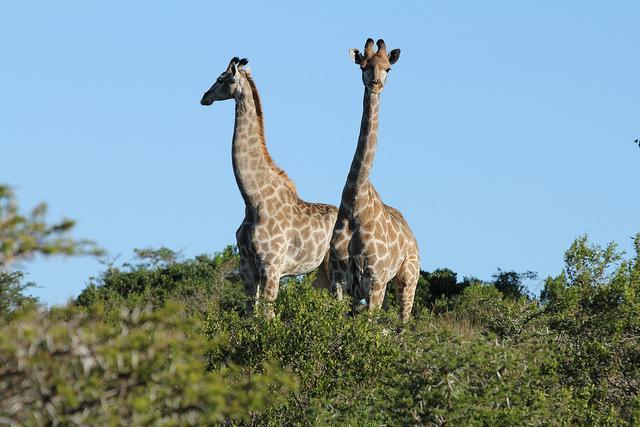How many giraffes are there?
Give a very brief answer. 2. How many horns do these animals have?
Give a very brief answer. 2. How many giraffes can be seen?
Give a very brief answer. 2. 